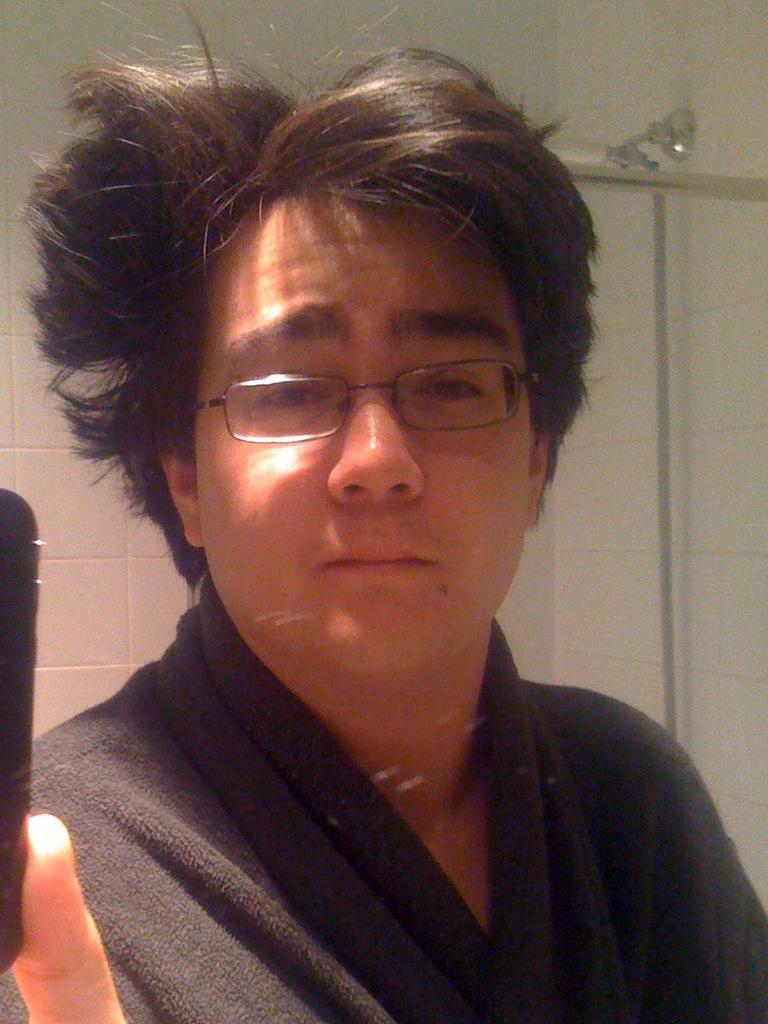What is the main subject of the image? The main subject of the image is a guy. Can you describe the guy's attire? The guy is wearing a black dress. What accessory is the guy wearing in the image? The guy is wearing spectacles. What type of wilderness can be seen in the background of the image? There is no wilderness visible in the image; it only features the guy wearing a black dress and spectacles. What kind of sponge is the guy using to clean his glasses in the image? There is no sponge present in the image, nor is the guy cleaning his glasses. 